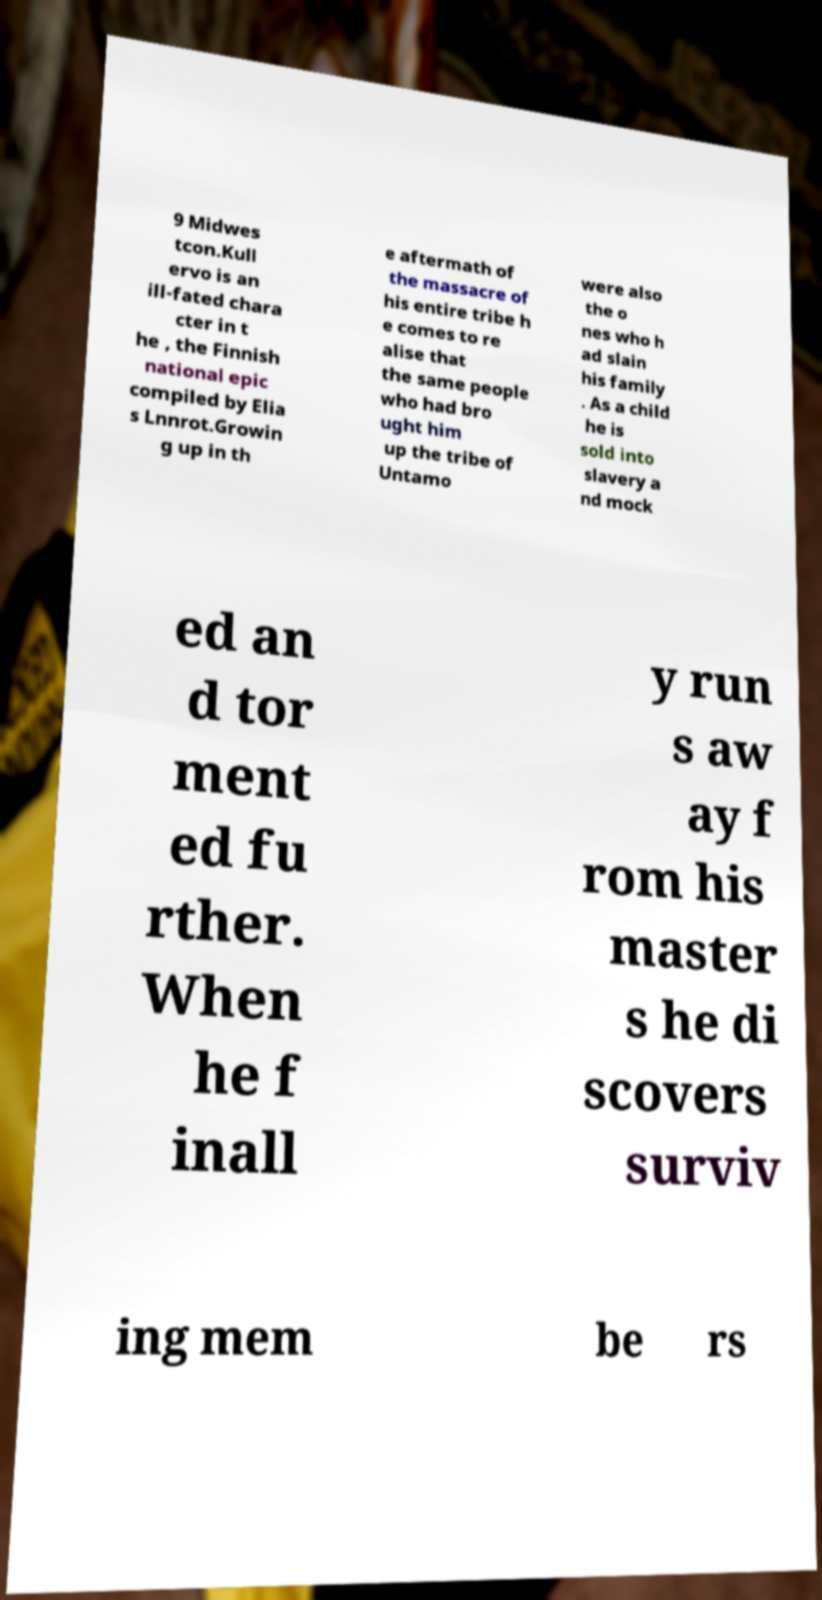For documentation purposes, I need the text within this image transcribed. Could you provide that? 9 Midwes tcon.Kull ervo is an ill-fated chara cter in t he , the Finnish national epic compiled by Elia s Lnnrot.Growin g up in th e aftermath of the massacre of his entire tribe h e comes to re alise that the same people who had bro ught him up the tribe of Untamo were also the o nes who h ad slain his family . As a child he is sold into slavery a nd mock ed an d tor ment ed fu rther. When he f inall y run s aw ay f rom his master s he di scovers surviv ing mem be rs 